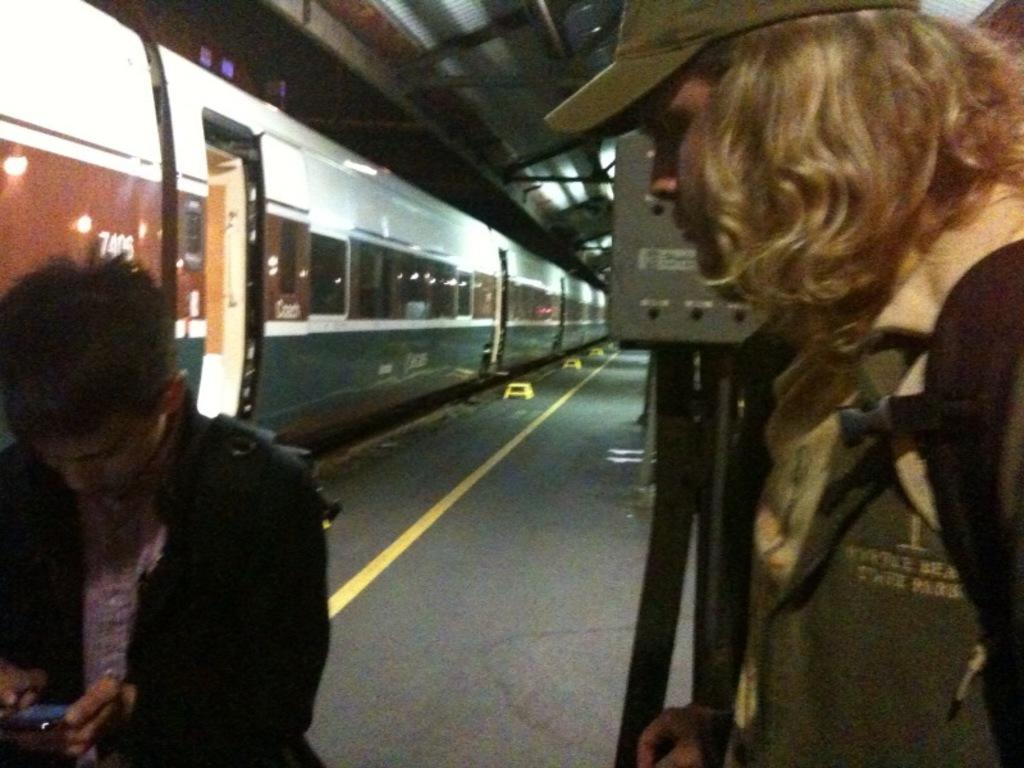What is the main subject of the image? The main subject of the image is a train. What is located beside the train? There is a platform beside the train. What can be seen on the platform? There is a stand on the platform. How many people are visible in the image? Two persons are visible in the image. What type of lace can be seen on the train in the image? There is no lace visible on the train in the image. What kind of mine is located near the train in the image? There is no mine present in the image; it features a train and a platform. 